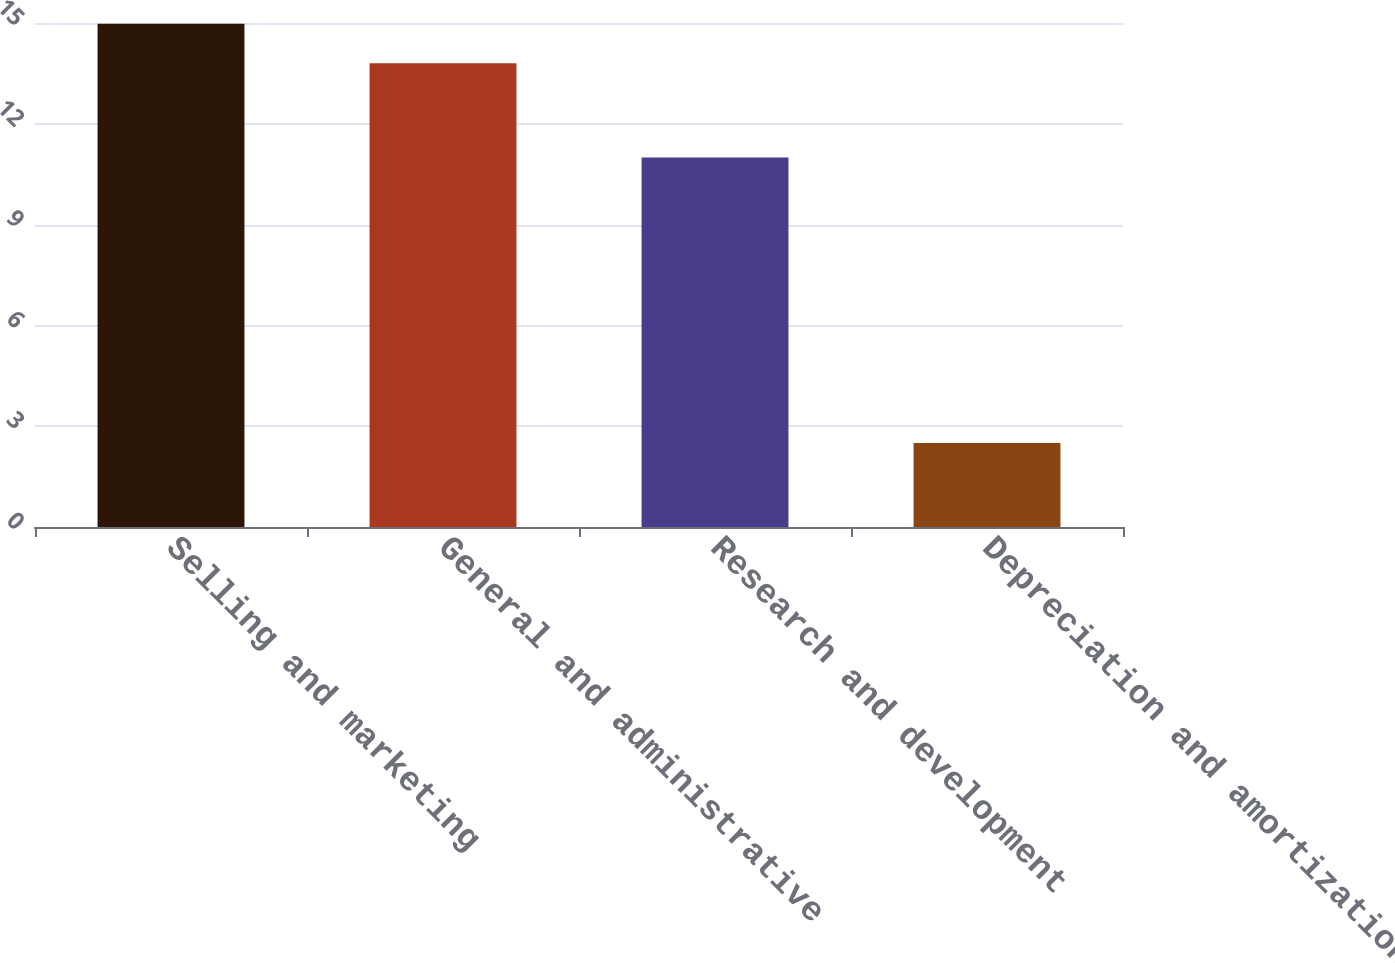<chart> <loc_0><loc_0><loc_500><loc_500><bar_chart><fcel>Selling and marketing<fcel>General and administrative<fcel>Research and development<fcel>Depreciation and amortization<nl><fcel>14.98<fcel>13.8<fcel>11<fcel>2.5<nl></chart> 